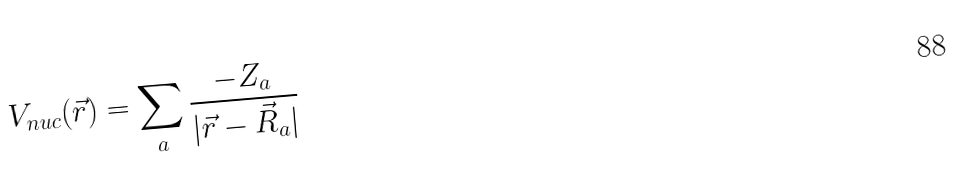Convert formula to latex. <formula><loc_0><loc_0><loc_500><loc_500>V _ { n u c } ( { \vec { r } } ) = \sum _ { a } \frac { - Z _ { a } } { | { \vec { r } } - { \vec { R } } _ { a } | }</formula> 